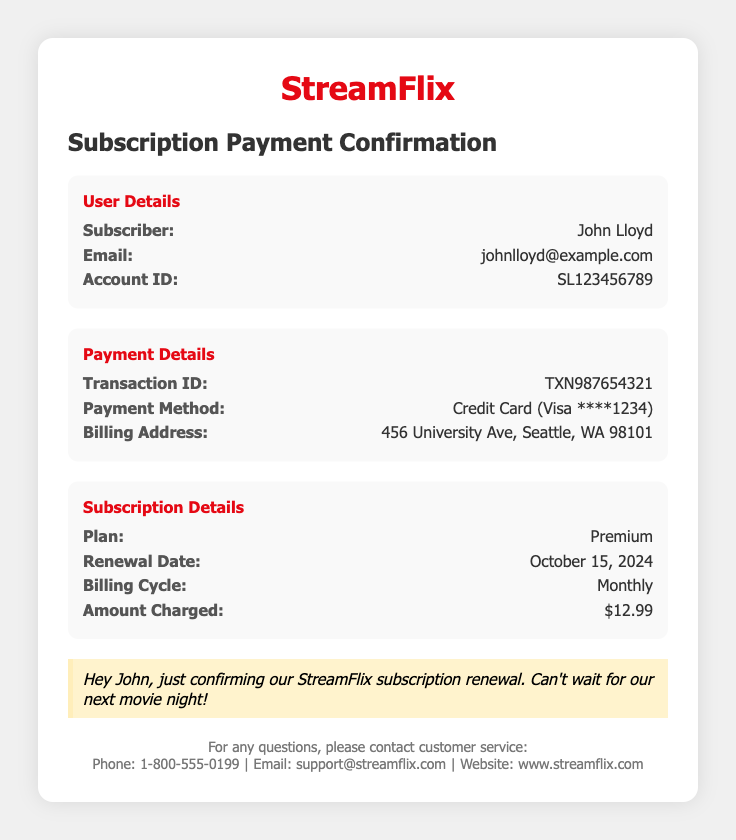What is the renewal date? The renewal date is specified in the subscription details section, which states October 15, 2024.
Answer: October 15, 2024 What is the payment method used? The payment method is mentioned under payment details, stating Credit Card (Visa ****1234).
Answer: Credit Card (Visa ****1234) Who is the subscriber? The subscriber's name is provided in the user details section, which mentions John Lloyd.
Answer: John Lloyd What is the amount charged for the subscription? The amount charged is listed in the subscription details section as $12.99.
Answer: $12.99 What is the billing cycle for the subscription? The billing cycle is detailed in the subscription section, specifically mentioned as Monthly.
Answer: Monthly What is the transaction ID? The transaction ID can be found in the payment details section, which lists TXN987654321.
Answer: TXN987654321 What is the plan type? The plan type is described in the subscription details as Premium.
Answer: Premium What is the email address associated with the subscription? The email address is provided in the user details section as johnlloyd@example.com.
Answer: johnlloyd@example.com 